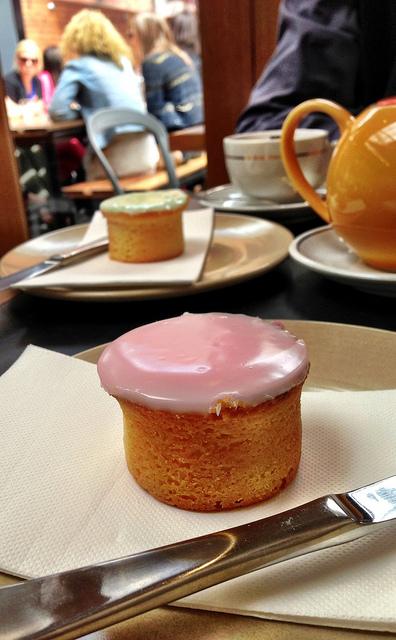How many desserts are in the photo?
Quick response, please. 2. What is this desert?
Write a very short answer. Cupcake. What color is the teapot?
Write a very short answer. Orange. 